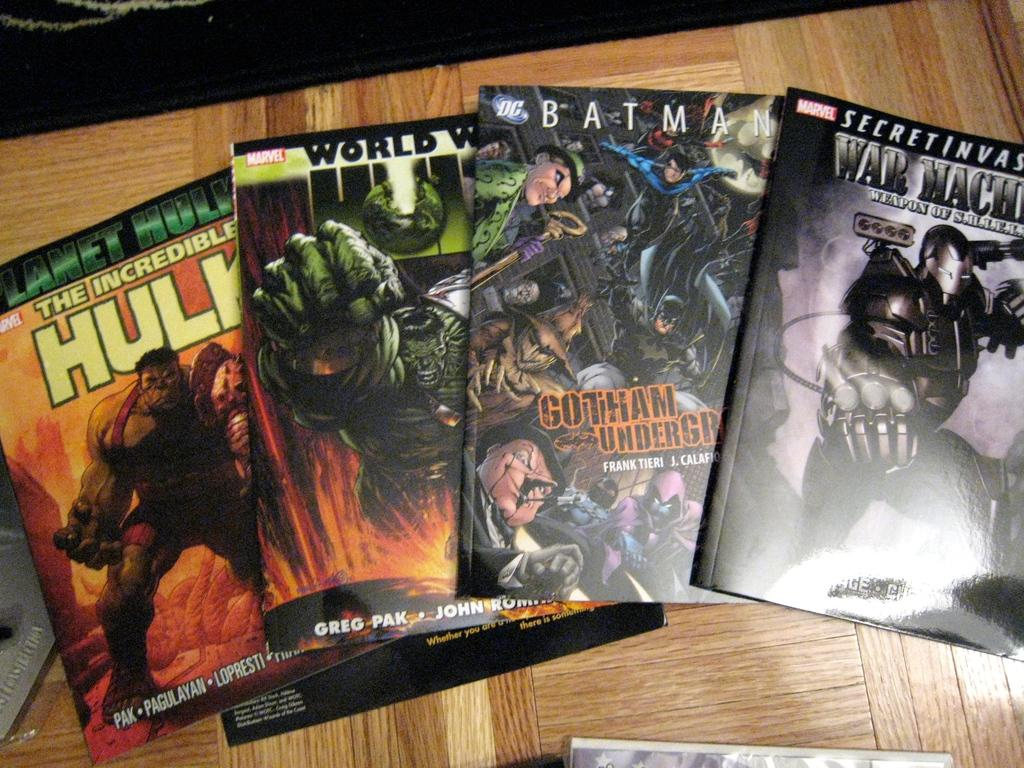<image>
Write a terse but informative summary of the picture. The second comic book from the right is Batman from the DC universe. 